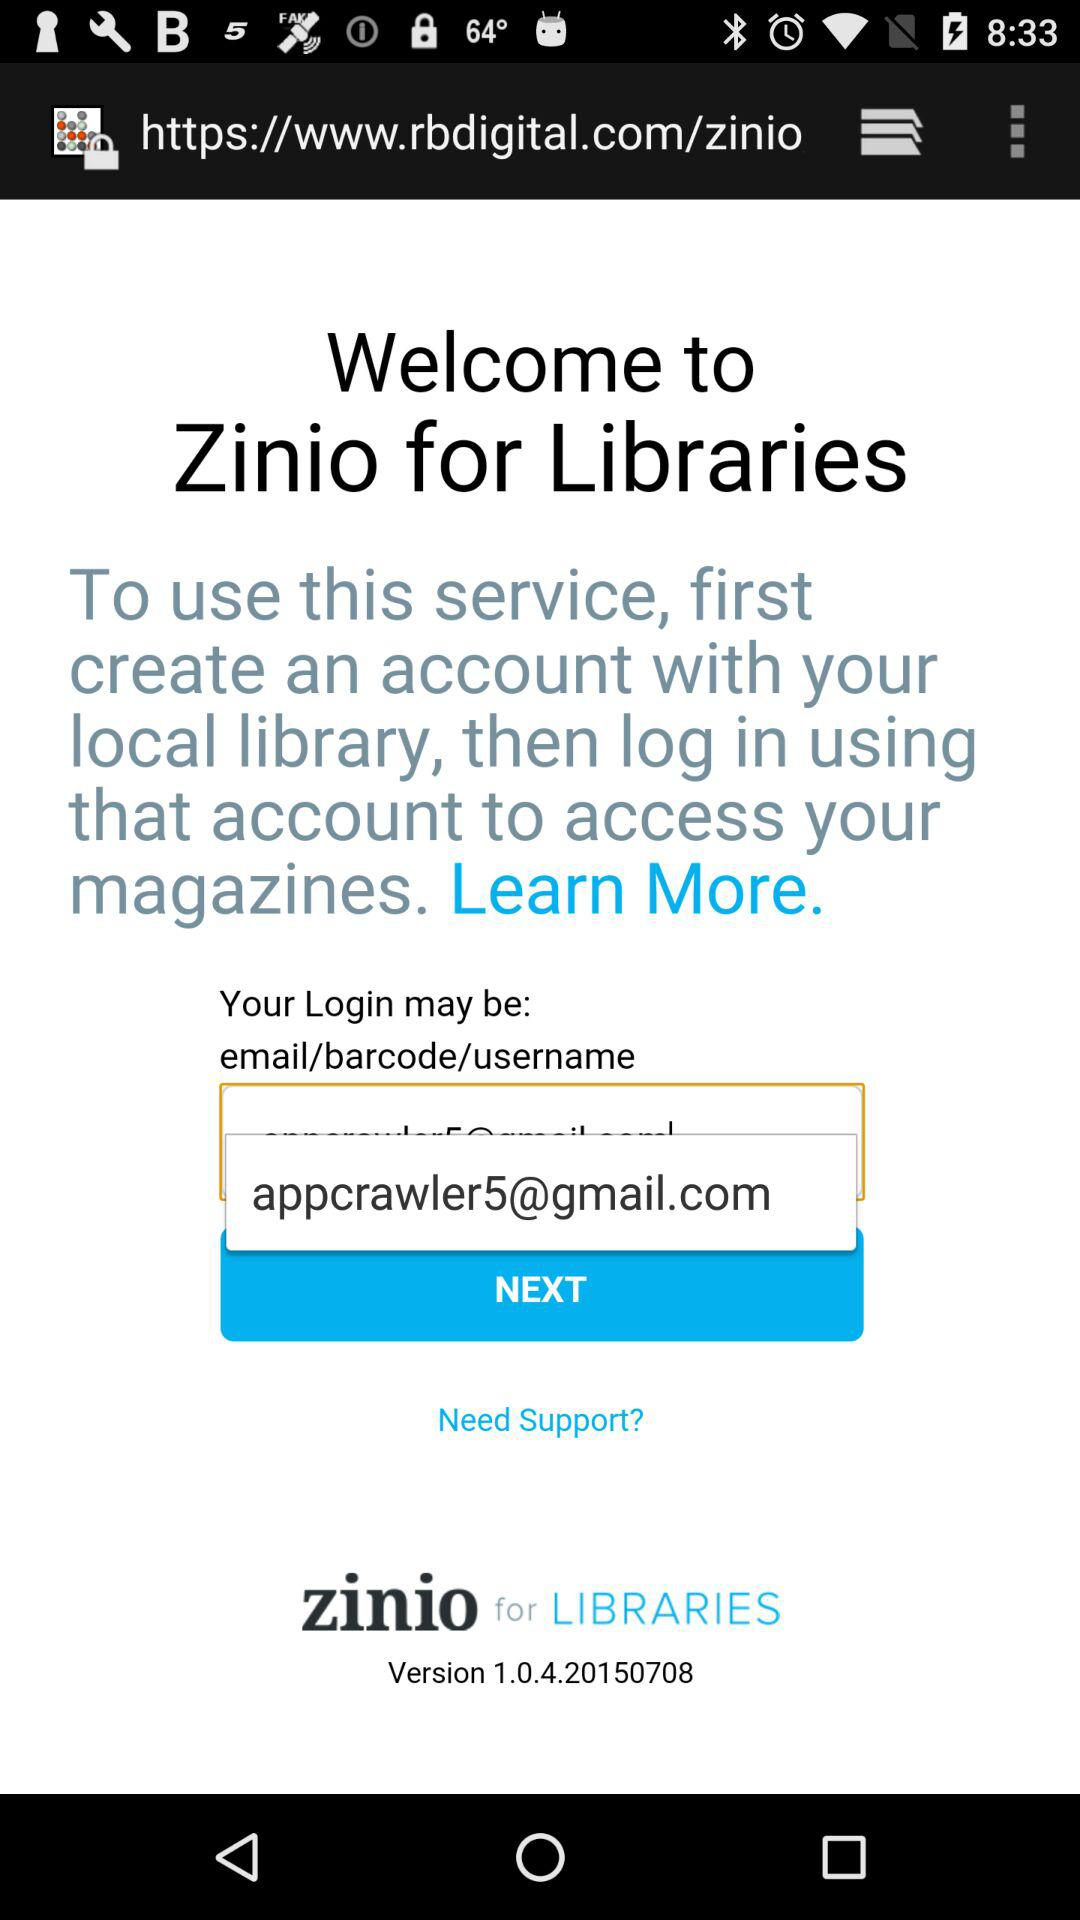Which version is used? The used version is 1.0.4.20150708. 